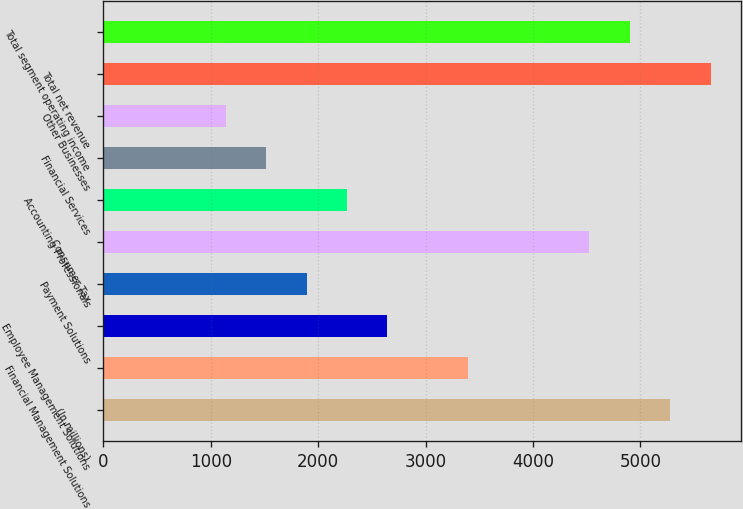Convert chart to OTSL. <chart><loc_0><loc_0><loc_500><loc_500><bar_chart><fcel>(In millions)<fcel>Financial Management Solutions<fcel>Employee Management Solutions<fcel>Payment Solutions<fcel>Consumer Tax<fcel>Accounting Professionals<fcel>Financial Services<fcel>Other Businesses<fcel>Total net revenue<fcel>Total segment operating income<nl><fcel>5276<fcel>3396<fcel>2644<fcel>1892<fcel>4524<fcel>2268<fcel>1516<fcel>1140<fcel>5652<fcel>4900<nl></chart> 